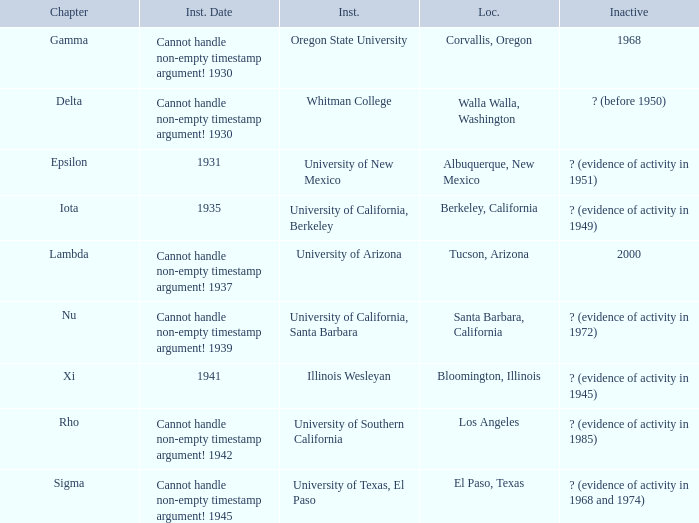What is the chapter for Illinois Wesleyan?  Xi. 